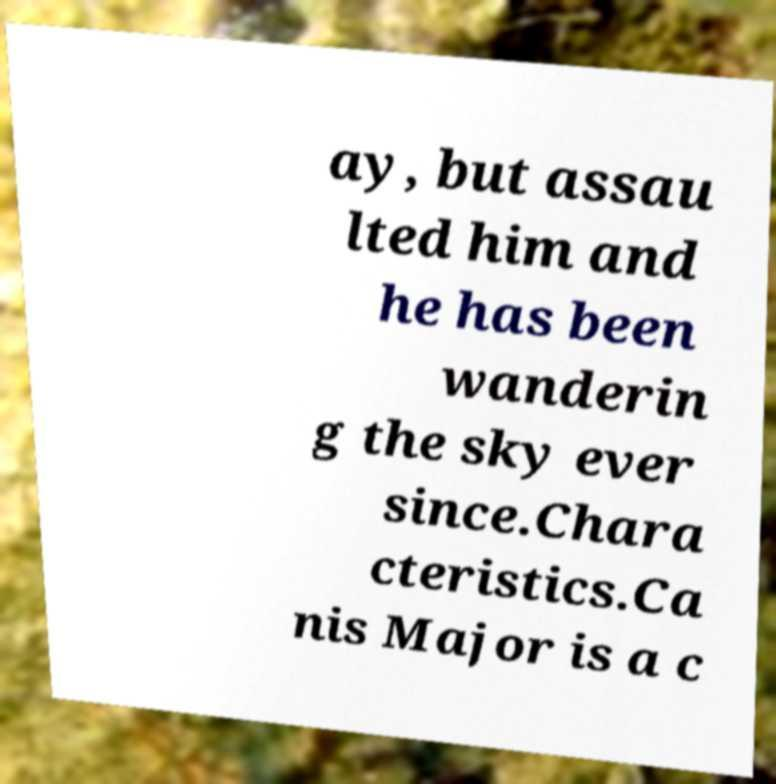There's text embedded in this image that I need extracted. Can you transcribe it verbatim? ay, but assau lted him and he has been wanderin g the sky ever since.Chara cteristics.Ca nis Major is a c 